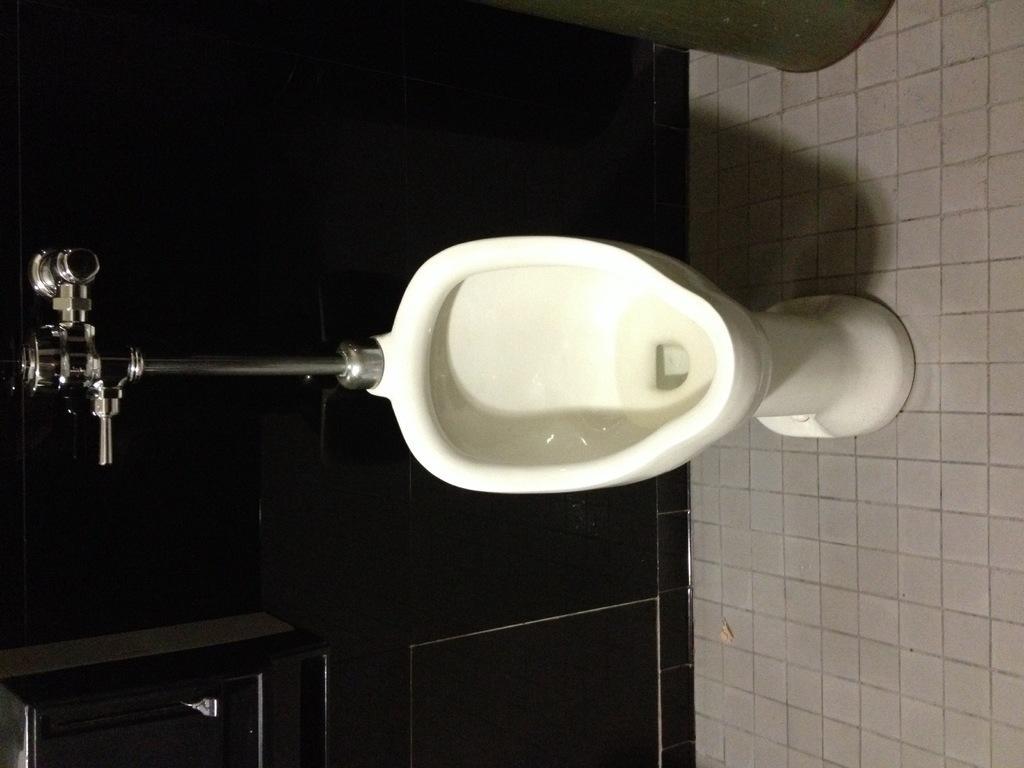Please provide a concise description of this image. In the center of the image there is a toilet seat. To the left side of the image there is tap. At the bottom of the image there is floor. 